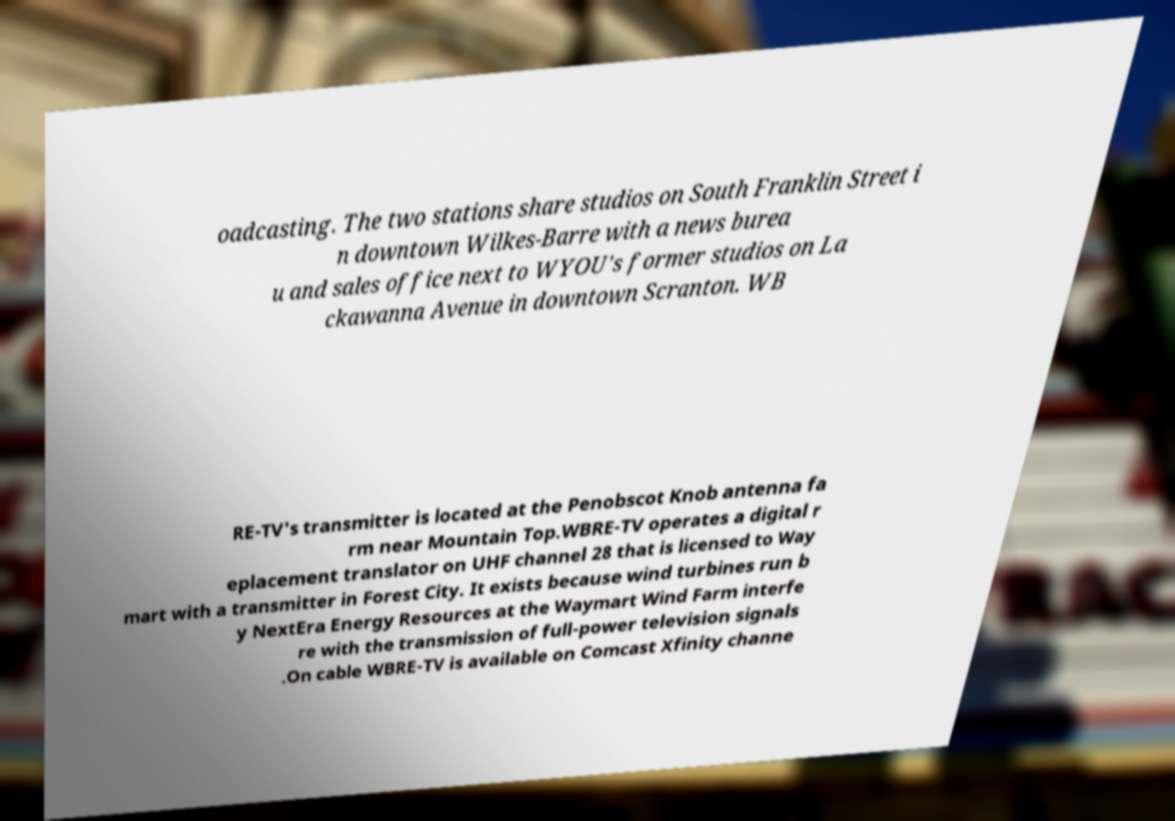I need the written content from this picture converted into text. Can you do that? oadcasting. The two stations share studios on South Franklin Street i n downtown Wilkes-Barre with a news burea u and sales office next to WYOU's former studios on La ckawanna Avenue in downtown Scranton. WB RE-TV's transmitter is located at the Penobscot Knob antenna fa rm near Mountain Top.WBRE-TV operates a digital r eplacement translator on UHF channel 28 that is licensed to Way mart with a transmitter in Forest City. It exists because wind turbines run b y NextEra Energy Resources at the Waymart Wind Farm interfe re with the transmission of full-power television signals .On cable WBRE-TV is available on Comcast Xfinity channe 